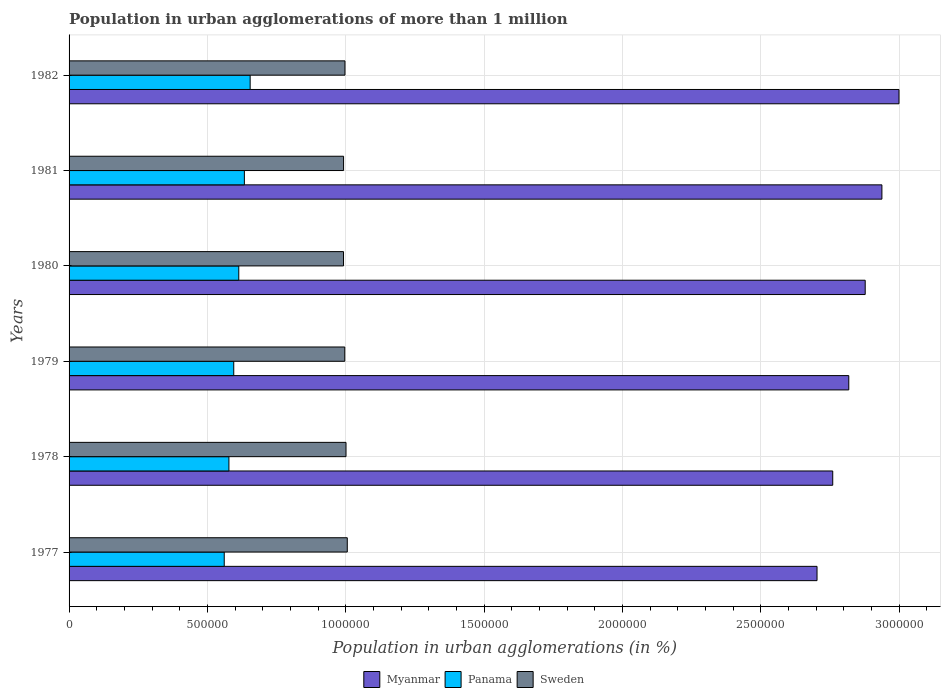How many groups of bars are there?
Provide a succinct answer. 6. Are the number of bars per tick equal to the number of legend labels?
Give a very brief answer. Yes. How many bars are there on the 4th tick from the bottom?
Keep it short and to the point. 3. What is the label of the 2nd group of bars from the top?
Your answer should be compact. 1981. In how many cases, is the number of bars for a given year not equal to the number of legend labels?
Provide a succinct answer. 0. What is the population in urban agglomerations in Panama in 1978?
Your answer should be compact. 5.78e+05. Across all years, what is the maximum population in urban agglomerations in Sweden?
Your answer should be very brief. 1.01e+06. Across all years, what is the minimum population in urban agglomerations in Sweden?
Your answer should be compact. 9.92e+05. In which year was the population in urban agglomerations in Sweden maximum?
Provide a short and direct response. 1977. What is the total population in urban agglomerations in Myanmar in the graph?
Make the answer very short. 1.71e+07. What is the difference between the population in urban agglomerations in Sweden in 1979 and that in 1980?
Provide a succinct answer. 4536. What is the difference between the population in urban agglomerations in Panama in 1981 and the population in urban agglomerations in Myanmar in 1977?
Provide a succinct answer. -2.07e+06. What is the average population in urban agglomerations in Myanmar per year?
Your answer should be very brief. 2.85e+06. In the year 1980, what is the difference between the population in urban agglomerations in Sweden and population in urban agglomerations in Panama?
Give a very brief answer. 3.78e+05. In how many years, is the population in urban agglomerations in Myanmar greater than 2500000 %?
Your answer should be compact. 6. What is the ratio of the population in urban agglomerations in Myanmar in 1979 to that in 1981?
Make the answer very short. 0.96. Is the population in urban agglomerations in Sweden in 1977 less than that in 1978?
Your response must be concise. No. Is the difference between the population in urban agglomerations in Sweden in 1977 and 1978 greater than the difference between the population in urban agglomerations in Panama in 1977 and 1978?
Your response must be concise. Yes. What is the difference between the highest and the second highest population in urban agglomerations in Panama?
Offer a terse response. 2.09e+04. What is the difference between the highest and the lowest population in urban agglomerations in Panama?
Provide a succinct answer. 9.36e+04. In how many years, is the population in urban agglomerations in Sweden greater than the average population in urban agglomerations in Sweden taken over all years?
Offer a very short reply. 2. What does the 3rd bar from the top in 1982 represents?
Provide a succinct answer. Myanmar. Are all the bars in the graph horizontal?
Your answer should be compact. Yes. What is the difference between two consecutive major ticks on the X-axis?
Ensure brevity in your answer.  5.00e+05. Where does the legend appear in the graph?
Your answer should be very brief. Bottom center. How many legend labels are there?
Offer a terse response. 3. What is the title of the graph?
Your response must be concise. Population in urban agglomerations of more than 1 million. What is the label or title of the X-axis?
Keep it short and to the point. Population in urban agglomerations (in %). What is the Population in urban agglomerations (in %) of Myanmar in 1977?
Make the answer very short. 2.70e+06. What is the Population in urban agglomerations (in %) in Panama in 1977?
Keep it short and to the point. 5.61e+05. What is the Population in urban agglomerations (in %) of Sweden in 1977?
Keep it short and to the point. 1.01e+06. What is the Population in urban agglomerations (in %) of Myanmar in 1978?
Provide a succinct answer. 2.76e+06. What is the Population in urban agglomerations (in %) of Panama in 1978?
Keep it short and to the point. 5.78e+05. What is the Population in urban agglomerations (in %) in Sweden in 1978?
Keep it short and to the point. 1.00e+06. What is the Population in urban agglomerations (in %) in Myanmar in 1979?
Your answer should be very brief. 2.82e+06. What is the Population in urban agglomerations (in %) in Panama in 1979?
Give a very brief answer. 5.95e+05. What is the Population in urban agglomerations (in %) of Sweden in 1979?
Offer a very short reply. 9.96e+05. What is the Population in urban agglomerations (in %) in Myanmar in 1980?
Provide a short and direct response. 2.88e+06. What is the Population in urban agglomerations (in %) in Panama in 1980?
Provide a succinct answer. 6.13e+05. What is the Population in urban agglomerations (in %) in Sweden in 1980?
Your answer should be compact. 9.92e+05. What is the Population in urban agglomerations (in %) of Myanmar in 1981?
Ensure brevity in your answer.  2.94e+06. What is the Population in urban agglomerations (in %) of Panama in 1981?
Ensure brevity in your answer.  6.33e+05. What is the Population in urban agglomerations (in %) of Sweden in 1981?
Offer a terse response. 9.92e+05. What is the Population in urban agglomerations (in %) of Myanmar in 1982?
Offer a terse response. 3.00e+06. What is the Population in urban agglomerations (in %) in Panama in 1982?
Offer a very short reply. 6.54e+05. What is the Population in urban agglomerations (in %) in Sweden in 1982?
Provide a succinct answer. 9.97e+05. Across all years, what is the maximum Population in urban agglomerations (in %) in Myanmar?
Provide a succinct answer. 3.00e+06. Across all years, what is the maximum Population in urban agglomerations (in %) in Panama?
Provide a succinct answer. 6.54e+05. Across all years, what is the maximum Population in urban agglomerations (in %) of Sweden?
Offer a very short reply. 1.01e+06. Across all years, what is the minimum Population in urban agglomerations (in %) in Myanmar?
Provide a short and direct response. 2.70e+06. Across all years, what is the minimum Population in urban agglomerations (in %) in Panama?
Your answer should be compact. 5.61e+05. Across all years, what is the minimum Population in urban agglomerations (in %) of Sweden?
Provide a short and direct response. 9.92e+05. What is the total Population in urban agglomerations (in %) of Myanmar in the graph?
Offer a very short reply. 1.71e+07. What is the total Population in urban agglomerations (in %) in Panama in the graph?
Your answer should be very brief. 3.63e+06. What is the total Population in urban agglomerations (in %) of Sweden in the graph?
Provide a succinct answer. 5.98e+06. What is the difference between the Population in urban agglomerations (in %) in Myanmar in 1977 and that in 1978?
Provide a short and direct response. -5.68e+04. What is the difference between the Population in urban agglomerations (in %) in Panama in 1977 and that in 1978?
Make the answer very short. -1.69e+04. What is the difference between the Population in urban agglomerations (in %) in Sweden in 1977 and that in 1978?
Your answer should be compact. 4571. What is the difference between the Population in urban agglomerations (in %) in Myanmar in 1977 and that in 1979?
Give a very brief answer. -1.15e+05. What is the difference between the Population in urban agglomerations (in %) in Panama in 1977 and that in 1979?
Your response must be concise. -3.44e+04. What is the difference between the Population in urban agglomerations (in %) in Sweden in 1977 and that in 1979?
Ensure brevity in your answer.  9121. What is the difference between the Population in urban agglomerations (in %) of Myanmar in 1977 and that in 1980?
Give a very brief answer. -1.74e+05. What is the difference between the Population in urban agglomerations (in %) of Panama in 1977 and that in 1980?
Ensure brevity in your answer.  -5.26e+04. What is the difference between the Population in urban agglomerations (in %) in Sweden in 1977 and that in 1980?
Provide a short and direct response. 1.37e+04. What is the difference between the Population in urban agglomerations (in %) of Myanmar in 1977 and that in 1981?
Offer a very short reply. -2.34e+05. What is the difference between the Population in urban agglomerations (in %) of Panama in 1977 and that in 1981?
Provide a succinct answer. -7.28e+04. What is the difference between the Population in urban agglomerations (in %) of Sweden in 1977 and that in 1981?
Provide a short and direct response. 1.34e+04. What is the difference between the Population in urban agglomerations (in %) in Myanmar in 1977 and that in 1982?
Offer a terse response. -2.96e+05. What is the difference between the Population in urban agglomerations (in %) of Panama in 1977 and that in 1982?
Your response must be concise. -9.36e+04. What is the difference between the Population in urban agglomerations (in %) of Sweden in 1977 and that in 1982?
Offer a terse response. 8364. What is the difference between the Population in urban agglomerations (in %) in Myanmar in 1978 and that in 1979?
Provide a short and direct response. -5.80e+04. What is the difference between the Population in urban agglomerations (in %) in Panama in 1978 and that in 1979?
Provide a short and direct response. -1.74e+04. What is the difference between the Population in urban agglomerations (in %) in Sweden in 1978 and that in 1979?
Provide a succinct answer. 4550. What is the difference between the Population in urban agglomerations (in %) in Myanmar in 1978 and that in 1980?
Your answer should be very brief. -1.17e+05. What is the difference between the Population in urban agglomerations (in %) of Panama in 1978 and that in 1980?
Keep it short and to the point. -3.56e+04. What is the difference between the Population in urban agglomerations (in %) in Sweden in 1978 and that in 1980?
Provide a short and direct response. 9086. What is the difference between the Population in urban agglomerations (in %) in Myanmar in 1978 and that in 1981?
Offer a terse response. -1.78e+05. What is the difference between the Population in urban agglomerations (in %) of Panama in 1978 and that in 1981?
Your answer should be very brief. -5.58e+04. What is the difference between the Population in urban agglomerations (in %) of Sweden in 1978 and that in 1981?
Your answer should be very brief. 8837. What is the difference between the Population in urban agglomerations (in %) of Myanmar in 1978 and that in 1982?
Give a very brief answer. -2.39e+05. What is the difference between the Population in urban agglomerations (in %) of Panama in 1978 and that in 1982?
Provide a short and direct response. -7.67e+04. What is the difference between the Population in urban agglomerations (in %) of Sweden in 1978 and that in 1982?
Offer a very short reply. 3793. What is the difference between the Population in urban agglomerations (in %) of Myanmar in 1979 and that in 1980?
Keep it short and to the point. -5.93e+04. What is the difference between the Population in urban agglomerations (in %) of Panama in 1979 and that in 1980?
Provide a succinct answer. -1.82e+04. What is the difference between the Population in urban agglomerations (in %) of Sweden in 1979 and that in 1980?
Keep it short and to the point. 4536. What is the difference between the Population in urban agglomerations (in %) in Myanmar in 1979 and that in 1981?
Your answer should be compact. -1.20e+05. What is the difference between the Population in urban agglomerations (in %) in Panama in 1979 and that in 1981?
Offer a terse response. -3.84e+04. What is the difference between the Population in urban agglomerations (in %) of Sweden in 1979 and that in 1981?
Offer a very short reply. 4287. What is the difference between the Population in urban agglomerations (in %) of Myanmar in 1979 and that in 1982?
Offer a terse response. -1.81e+05. What is the difference between the Population in urban agglomerations (in %) in Panama in 1979 and that in 1982?
Keep it short and to the point. -5.93e+04. What is the difference between the Population in urban agglomerations (in %) in Sweden in 1979 and that in 1982?
Keep it short and to the point. -757. What is the difference between the Population in urban agglomerations (in %) in Myanmar in 1980 and that in 1981?
Ensure brevity in your answer.  -6.04e+04. What is the difference between the Population in urban agglomerations (in %) of Panama in 1980 and that in 1981?
Keep it short and to the point. -2.02e+04. What is the difference between the Population in urban agglomerations (in %) in Sweden in 1980 and that in 1981?
Keep it short and to the point. -249. What is the difference between the Population in urban agglomerations (in %) of Myanmar in 1980 and that in 1982?
Your response must be concise. -1.22e+05. What is the difference between the Population in urban agglomerations (in %) in Panama in 1980 and that in 1982?
Your answer should be very brief. -4.11e+04. What is the difference between the Population in urban agglomerations (in %) of Sweden in 1980 and that in 1982?
Your response must be concise. -5293. What is the difference between the Population in urban agglomerations (in %) in Myanmar in 1981 and that in 1982?
Offer a very short reply. -6.17e+04. What is the difference between the Population in urban agglomerations (in %) of Panama in 1981 and that in 1982?
Offer a very short reply. -2.09e+04. What is the difference between the Population in urban agglomerations (in %) in Sweden in 1981 and that in 1982?
Make the answer very short. -5044. What is the difference between the Population in urban agglomerations (in %) in Myanmar in 1977 and the Population in urban agglomerations (in %) in Panama in 1978?
Offer a very short reply. 2.13e+06. What is the difference between the Population in urban agglomerations (in %) in Myanmar in 1977 and the Population in urban agglomerations (in %) in Sweden in 1978?
Your answer should be compact. 1.70e+06. What is the difference between the Population in urban agglomerations (in %) of Panama in 1977 and the Population in urban agglomerations (in %) of Sweden in 1978?
Keep it short and to the point. -4.40e+05. What is the difference between the Population in urban agglomerations (in %) of Myanmar in 1977 and the Population in urban agglomerations (in %) of Panama in 1979?
Your answer should be very brief. 2.11e+06. What is the difference between the Population in urban agglomerations (in %) of Myanmar in 1977 and the Population in urban agglomerations (in %) of Sweden in 1979?
Provide a short and direct response. 1.71e+06. What is the difference between the Population in urban agglomerations (in %) of Panama in 1977 and the Population in urban agglomerations (in %) of Sweden in 1979?
Ensure brevity in your answer.  -4.36e+05. What is the difference between the Population in urban agglomerations (in %) of Myanmar in 1977 and the Population in urban agglomerations (in %) of Panama in 1980?
Ensure brevity in your answer.  2.09e+06. What is the difference between the Population in urban agglomerations (in %) in Myanmar in 1977 and the Population in urban agglomerations (in %) in Sweden in 1980?
Provide a short and direct response. 1.71e+06. What is the difference between the Population in urban agglomerations (in %) in Panama in 1977 and the Population in urban agglomerations (in %) in Sweden in 1980?
Give a very brief answer. -4.31e+05. What is the difference between the Population in urban agglomerations (in %) of Myanmar in 1977 and the Population in urban agglomerations (in %) of Panama in 1981?
Your answer should be compact. 2.07e+06. What is the difference between the Population in urban agglomerations (in %) in Myanmar in 1977 and the Population in urban agglomerations (in %) in Sweden in 1981?
Your response must be concise. 1.71e+06. What is the difference between the Population in urban agglomerations (in %) of Panama in 1977 and the Population in urban agglomerations (in %) of Sweden in 1981?
Make the answer very short. -4.31e+05. What is the difference between the Population in urban agglomerations (in %) in Myanmar in 1977 and the Population in urban agglomerations (in %) in Panama in 1982?
Provide a short and direct response. 2.05e+06. What is the difference between the Population in urban agglomerations (in %) of Myanmar in 1977 and the Population in urban agglomerations (in %) of Sweden in 1982?
Your answer should be very brief. 1.71e+06. What is the difference between the Population in urban agglomerations (in %) of Panama in 1977 and the Population in urban agglomerations (in %) of Sweden in 1982?
Provide a succinct answer. -4.36e+05. What is the difference between the Population in urban agglomerations (in %) of Myanmar in 1978 and the Population in urban agglomerations (in %) of Panama in 1979?
Give a very brief answer. 2.16e+06. What is the difference between the Population in urban agglomerations (in %) of Myanmar in 1978 and the Population in urban agglomerations (in %) of Sweden in 1979?
Your response must be concise. 1.76e+06. What is the difference between the Population in urban agglomerations (in %) in Panama in 1978 and the Population in urban agglomerations (in %) in Sweden in 1979?
Offer a very short reply. -4.19e+05. What is the difference between the Population in urban agglomerations (in %) in Myanmar in 1978 and the Population in urban agglomerations (in %) in Panama in 1980?
Ensure brevity in your answer.  2.15e+06. What is the difference between the Population in urban agglomerations (in %) in Myanmar in 1978 and the Population in urban agglomerations (in %) in Sweden in 1980?
Provide a succinct answer. 1.77e+06. What is the difference between the Population in urban agglomerations (in %) of Panama in 1978 and the Population in urban agglomerations (in %) of Sweden in 1980?
Make the answer very short. -4.14e+05. What is the difference between the Population in urban agglomerations (in %) of Myanmar in 1978 and the Population in urban agglomerations (in %) of Panama in 1981?
Provide a succinct answer. 2.13e+06. What is the difference between the Population in urban agglomerations (in %) in Myanmar in 1978 and the Population in urban agglomerations (in %) in Sweden in 1981?
Your response must be concise. 1.77e+06. What is the difference between the Population in urban agglomerations (in %) in Panama in 1978 and the Population in urban agglomerations (in %) in Sweden in 1981?
Offer a terse response. -4.14e+05. What is the difference between the Population in urban agglomerations (in %) in Myanmar in 1978 and the Population in urban agglomerations (in %) in Panama in 1982?
Ensure brevity in your answer.  2.11e+06. What is the difference between the Population in urban agglomerations (in %) of Myanmar in 1978 and the Population in urban agglomerations (in %) of Sweden in 1982?
Your answer should be very brief. 1.76e+06. What is the difference between the Population in urban agglomerations (in %) of Panama in 1978 and the Population in urban agglomerations (in %) of Sweden in 1982?
Your response must be concise. -4.19e+05. What is the difference between the Population in urban agglomerations (in %) in Myanmar in 1979 and the Population in urban agglomerations (in %) in Panama in 1980?
Offer a very short reply. 2.20e+06. What is the difference between the Population in urban agglomerations (in %) in Myanmar in 1979 and the Population in urban agglomerations (in %) in Sweden in 1980?
Provide a succinct answer. 1.83e+06. What is the difference between the Population in urban agglomerations (in %) of Panama in 1979 and the Population in urban agglomerations (in %) of Sweden in 1980?
Give a very brief answer. -3.97e+05. What is the difference between the Population in urban agglomerations (in %) in Myanmar in 1979 and the Population in urban agglomerations (in %) in Panama in 1981?
Provide a short and direct response. 2.18e+06. What is the difference between the Population in urban agglomerations (in %) of Myanmar in 1979 and the Population in urban agglomerations (in %) of Sweden in 1981?
Give a very brief answer. 1.83e+06. What is the difference between the Population in urban agglomerations (in %) in Panama in 1979 and the Population in urban agglomerations (in %) in Sweden in 1981?
Offer a very short reply. -3.97e+05. What is the difference between the Population in urban agglomerations (in %) in Myanmar in 1979 and the Population in urban agglomerations (in %) in Panama in 1982?
Your response must be concise. 2.16e+06. What is the difference between the Population in urban agglomerations (in %) of Myanmar in 1979 and the Population in urban agglomerations (in %) of Sweden in 1982?
Make the answer very short. 1.82e+06. What is the difference between the Population in urban agglomerations (in %) of Panama in 1979 and the Population in urban agglomerations (in %) of Sweden in 1982?
Make the answer very short. -4.02e+05. What is the difference between the Population in urban agglomerations (in %) of Myanmar in 1980 and the Population in urban agglomerations (in %) of Panama in 1981?
Ensure brevity in your answer.  2.24e+06. What is the difference between the Population in urban agglomerations (in %) in Myanmar in 1980 and the Population in urban agglomerations (in %) in Sweden in 1981?
Make the answer very short. 1.88e+06. What is the difference between the Population in urban agglomerations (in %) in Panama in 1980 and the Population in urban agglomerations (in %) in Sweden in 1981?
Ensure brevity in your answer.  -3.79e+05. What is the difference between the Population in urban agglomerations (in %) of Myanmar in 1980 and the Population in urban agglomerations (in %) of Panama in 1982?
Your response must be concise. 2.22e+06. What is the difference between the Population in urban agglomerations (in %) in Myanmar in 1980 and the Population in urban agglomerations (in %) in Sweden in 1982?
Your answer should be compact. 1.88e+06. What is the difference between the Population in urban agglomerations (in %) of Panama in 1980 and the Population in urban agglomerations (in %) of Sweden in 1982?
Make the answer very short. -3.84e+05. What is the difference between the Population in urban agglomerations (in %) of Myanmar in 1981 and the Population in urban agglomerations (in %) of Panama in 1982?
Your response must be concise. 2.28e+06. What is the difference between the Population in urban agglomerations (in %) in Myanmar in 1981 and the Population in urban agglomerations (in %) in Sweden in 1982?
Provide a succinct answer. 1.94e+06. What is the difference between the Population in urban agglomerations (in %) of Panama in 1981 and the Population in urban agglomerations (in %) of Sweden in 1982?
Offer a very short reply. -3.64e+05. What is the average Population in urban agglomerations (in %) in Myanmar per year?
Give a very brief answer. 2.85e+06. What is the average Population in urban agglomerations (in %) of Panama per year?
Offer a terse response. 6.06e+05. What is the average Population in urban agglomerations (in %) in Sweden per year?
Give a very brief answer. 9.97e+05. In the year 1977, what is the difference between the Population in urban agglomerations (in %) of Myanmar and Population in urban agglomerations (in %) of Panama?
Offer a very short reply. 2.14e+06. In the year 1977, what is the difference between the Population in urban agglomerations (in %) in Myanmar and Population in urban agglomerations (in %) in Sweden?
Keep it short and to the point. 1.70e+06. In the year 1977, what is the difference between the Population in urban agglomerations (in %) in Panama and Population in urban agglomerations (in %) in Sweden?
Ensure brevity in your answer.  -4.45e+05. In the year 1978, what is the difference between the Population in urban agglomerations (in %) of Myanmar and Population in urban agglomerations (in %) of Panama?
Provide a succinct answer. 2.18e+06. In the year 1978, what is the difference between the Population in urban agglomerations (in %) of Myanmar and Population in urban agglomerations (in %) of Sweden?
Provide a succinct answer. 1.76e+06. In the year 1978, what is the difference between the Population in urban agglomerations (in %) of Panama and Population in urban agglomerations (in %) of Sweden?
Provide a short and direct response. -4.23e+05. In the year 1979, what is the difference between the Population in urban agglomerations (in %) in Myanmar and Population in urban agglomerations (in %) in Panama?
Ensure brevity in your answer.  2.22e+06. In the year 1979, what is the difference between the Population in urban agglomerations (in %) in Myanmar and Population in urban agglomerations (in %) in Sweden?
Ensure brevity in your answer.  1.82e+06. In the year 1979, what is the difference between the Population in urban agglomerations (in %) of Panama and Population in urban agglomerations (in %) of Sweden?
Your response must be concise. -4.01e+05. In the year 1980, what is the difference between the Population in urban agglomerations (in %) in Myanmar and Population in urban agglomerations (in %) in Panama?
Give a very brief answer. 2.26e+06. In the year 1980, what is the difference between the Population in urban agglomerations (in %) of Myanmar and Population in urban agglomerations (in %) of Sweden?
Keep it short and to the point. 1.89e+06. In the year 1980, what is the difference between the Population in urban agglomerations (in %) in Panama and Population in urban agglomerations (in %) in Sweden?
Offer a very short reply. -3.78e+05. In the year 1981, what is the difference between the Population in urban agglomerations (in %) in Myanmar and Population in urban agglomerations (in %) in Panama?
Ensure brevity in your answer.  2.30e+06. In the year 1981, what is the difference between the Population in urban agglomerations (in %) in Myanmar and Population in urban agglomerations (in %) in Sweden?
Keep it short and to the point. 1.95e+06. In the year 1981, what is the difference between the Population in urban agglomerations (in %) in Panama and Population in urban agglomerations (in %) in Sweden?
Your answer should be compact. -3.58e+05. In the year 1982, what is the difference between the Population in urban agglomerations (in %) of Myanmar and Population in urban agglomerations (in %) of Panama?
Your answer should be compact. 2.34e+06. In the year 1982, what is the difference between the Population in urban agglomerations (in %) of Myanmar and Population in urban agglomerations (in %) of Sweden?
Offer a very short reply. 2.00e+06. In the year 1982, what is the difference between the Population in urban agglomerations (in %) of Panama and Population in urban agglomerations (in %) of Sweden?
Your answer should be very brief. -3.43e+05. What is the ratio of the Population in urban agglomerations (in %) in Myanmar in 1977 to that in 1978?
Provide a short and direct response. 0.98. What is the ratio of the Population in urban agglomerations (in %) in Panama in 1977 to that in 1978?
Keep it short and to the point. 0.97. What is the ratio of the Population in urban agglomerations (in %) in Sweden in 1977 to that in 1978?
Ensure brevity in your answer.  1. What is the ratio of the Population in urban agglomerations (in %) in Myanmar in 1977 to that in 1979?
Provide a short and direct response. 0.96. What is the ratio of the Population in urban agglomerations (in %) of Panama in 1977 to that in 1979?
Provide a succinct answer. 0.94. What is the ratio of the Population in urban agglomerations (in %) of Sweden in 1977 to that in 1979?
Offer a terse response. 1.01. What is the ratio of the Population in urban agglomerations (in %) in Myanmar in 1977 to that in 1980?
Ensure brevity in your answer.  0.94. What is the ratio of the Population in urban agglomerations (in %) in Panama in 1977 to that in 1980?
Keep it short and to the point. 0.91. What is the ratio of the Population in urban agglomerations (in %) of Sweden in 1977 to that in 1980?
Offer a very short reply. 1.01. What is the ratio of the Population in urban agglomerations (in %) in Myanmar in 1977 to that in 1981?
Ensure brevity in your answer.  0.92. What is the ratio of the Population in urban agglomerations (in %) in Panama in 1977 to that in 1981?
Your answer should be very brief. 0.89. What is the ratio of the Population in urban agglomerations (in %) in Sweden in 1977 to that in 1981?
Give a very brief answer. 1.01. What is the ratio of the Population in urban agglomerations (in %) in Myanmar in 1977 to that in 1982?
Make the answer very short. 0.9. What is the ratio of the Population in urban agglomerations (in %) in Panama in 1977 to that in 1982?
Your response must be concise. 0.86. What is the ratio of the Population in urban agglomerations (in %) of Sweden in 1977 to that in 1982?
Make the answer very short. 1.01. What is the ratio of the Population in urban agglomerations (in %) in Myanmar in 1978 to that in 1979?
Offer a terse response. 0.98. What is the ratio of the Population in urban agglomerations (in %) of Panama in 1978 to that in 1979?
Make the answer very short. 0.97. What is the ratio of the Population in urban agglomerations (in %) in Sweden in 1978 to that in 1979?
Give a very brief answer. 1. What is the ratio of the Population in urban agglomerations (in %) in Myanmar in 1978 to that in 1980?
Provide a succinct answer. 0.96. What is the ratio of the Population in urban agglomerations (in %) in Panama in 1978 to that in 1980?
Make the answer very short. 0.94. What is the ratio of the Population in urban agglomerations (in %) of Sweden in 1978 to that in 1980?
Keep it short and to the point. 1.01. What is the ratio of the Population in urban agglomerations (in %) of Myanmar in 1978 to that in 1981?
Give a very brief answer. 0.94. What is the ratio of the Population in urban agglomerations (in %) of Panama in 1978 to that in 1981?
Provide a succinct answer. 0.91. What is the ratio of the Population in urban agglomerations (in %) of Sweden in 1978 to that in 1981?
Provide a succinct answer. 1.01. What is the ratio of the Population in urban agglomerations (in %) of Myanmar in 1978 to that in 1982?
Offer a very short reply. 0.92. What is the ratio of the Population in urban agglomerations (in %) of Panama in 1978 to that in 1982?
Your answer should be very brief. 0.88. What is the ratio of the Population in urban agglomerations (in %) of Sweden in 1978 to that in 1982?
Your response must be concise. 1. What is the ratio of the Population in urban agglomerations (in %) of Myanmar in 1979 to that in 1980?
Your answer should be very brief. 0.98. What is the ratio of the Population in urban agglomerations (in %) in Panama in 1979 to that in 1980?
Make the answer very short. 0.97. What is the ratio of the Population in urban agglomerations (in %) of Sweden in 1979 to that in 1980?
Make the answer very short. 1. What is the ratio of the Population in urban agglomerations (in %) in Myanmar in 1979 to that in 1981?
Give a very brief answer. 0.96. What is the ratio of the Population in urban agglomerations (in %) in Panama in 1979 to that in 1981?
Provide a succinct answer. 0.94. What is the ratio of the Population in urban agglomerations (in %) in Myanmar in 1979 to that in 1982?
Offer a very short reply. 0.94. What is the ratio of the Population in urban agglomerations (in %) of Panama in 1979 to that in 1982?
Keep it short and to the point. 0.91. What is the ratio of the Population in urban agglomerations (in %) of Sweden in 1979 to that in 1982?
Give a very brief answer. 1. What is the ratio of the Population in urban agglomerations (in %) in Myanmar in 1980 to that in 1981?
Give a very brief answer. 0.98. What is the ratio of the Population in urban agglomerations (in %) of Panama in 1980 to that in 1981?
Offer a very short reply. 0.97. What is the ratio of the Population in urban agglomerations (in %) in Sweden in 1980 to that in 1981?
Your response must be concise. 1. What is the ratio of the Population in urban agglomerations (in %) in Myanmar in 1980 to that in 1982?
Keep it short and to the point. 0.96. What is the ratio of the Population in urban agglomerations (in %) in Panama in 1980 to that in 1982?
Ensure brevity in your answer.  0.94. What is the ratio of the Population in urban agglomerations (in %) of Myanmar in 1981 to that in 1982?
Ensure brevity in your answer.  0.98. What is the ratio of the Population in urban agglomerations (in %) in Panama in 1981 to that in 1982?
Provide a succinct answer. 0.97. What is the difference between the highest and the second highest Population in urban agglomerations (in %) of Myanmar?
Keep it short and to the point. 6.17e+04. What is the difference between the highest and the second highest Population in urban agglomerations (in %) of Panama?
Keep it short and to the point. 2.09e+04. What is the difference between the highest and the second highest Population in urban agglomerations (in %) of Sweden?
Provide a succinct answer. 4571. What is the difference between the highest and the lowest Population in urban agglomerations (in %) in Myanmar?
Offer a very short reply. 2.96e+05. What is the difference between the highest and the lowest Population in urban agglomerations (in %) in Panama?
Provide a succinct answer. 9.36e+04. What is the difference between the highest and the lowest Population in urban agglomerations (in %) of Sweden?
Your answer should be compact. 1.37e+04. 